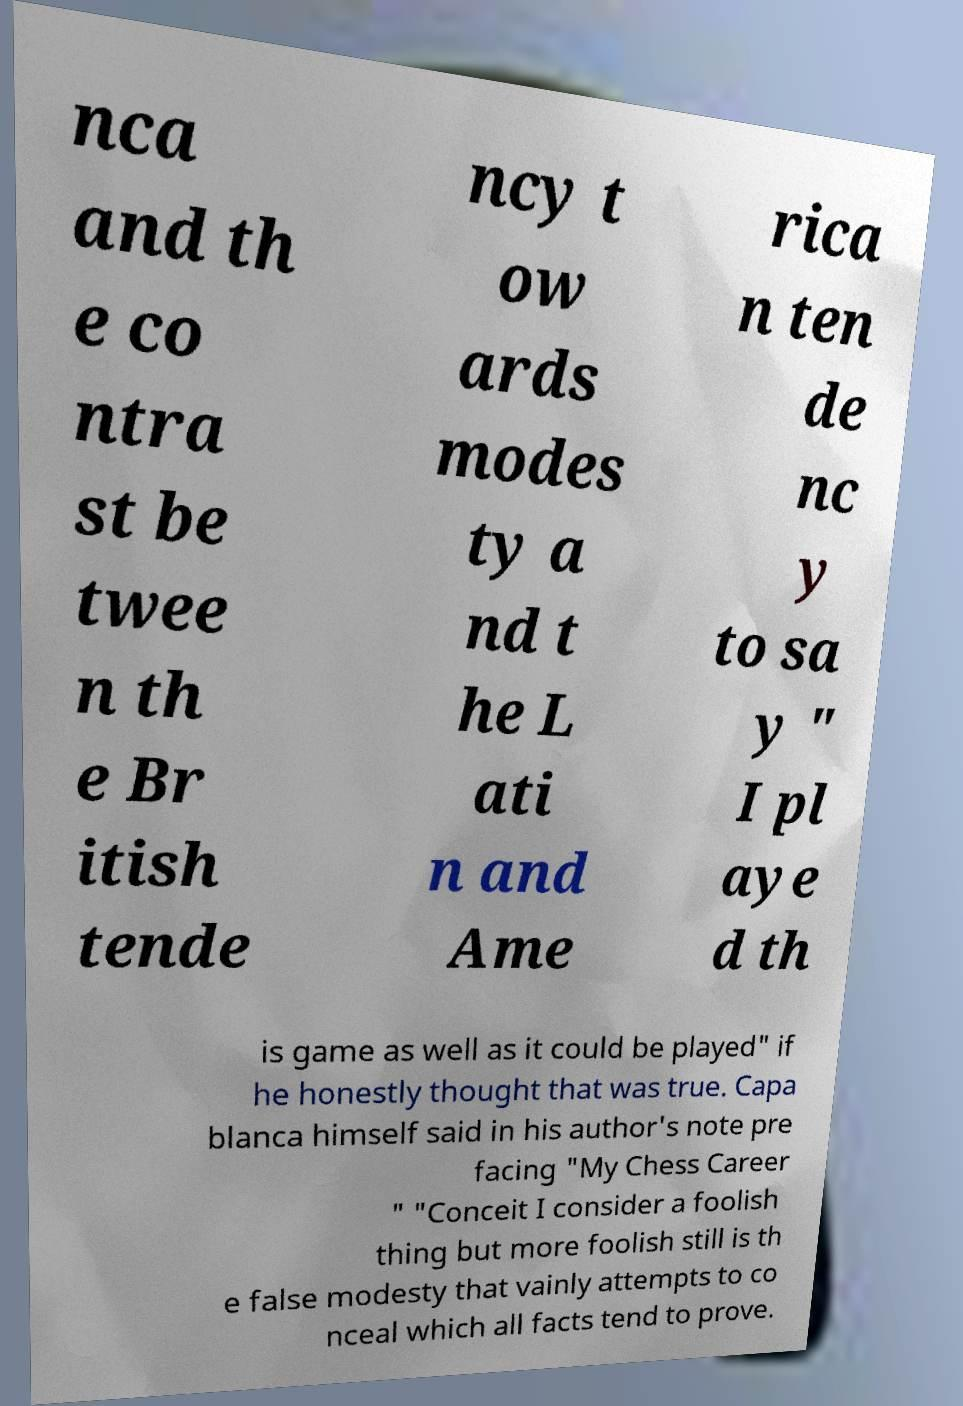Please read and relay the text visible in this image. What does it say? nca and th e co ntra st be twee n th e Br itish tende ncy t ow ards modes ty a nd t he L ati n and Ame rica n ten de nc y to sa y " I pl aye d th is game as well as it could be played" if he honestly thought that was true. Capa blanca himself said in his author's note pre facing "My Chess Career " "Conceit I consider a foolish thing but more foolish still is th e false modesty that vainly attempts to co nceal which all facts tend to prove. 